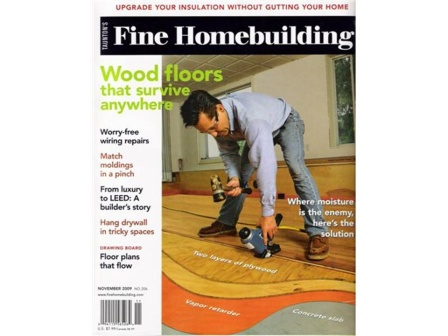What are the key elements in this picture? The image is a cover of a magazine titled "Fine Homebuilding". Prominently featured in the center is a man wearing a blue shirt and jeans, who is kneeling on a wooden floor, focused intently on his work. He holds a hammer and is working on a section of the floor highlighted in red. Surrounding him, the cover is abundant with text, hinting at the magazine's content. Phrases like "Wood floors that survive anywhere", "Worry-free wiring repairs", "Match moldings in a pinch", "From luxury to LEED: A builder's story", "Hang drywall in tricky spaces", "Floor plans that flow", and "Where there's moisture, there's a solution" provide insights into the practical advice and solutions the magazine offers. Dated November 2010, the cover suggests that while the content might be a decade old, it remains relevant for enthusiasts of homebuilding and repair. 